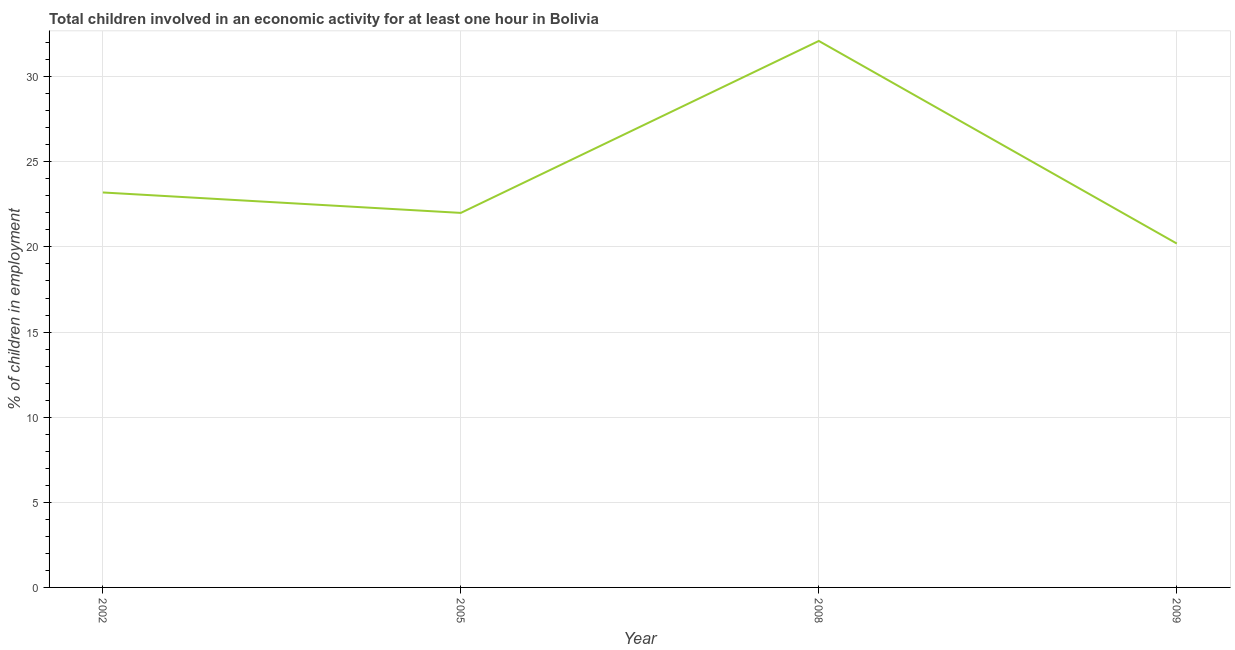What is the percentage of children in employment in 2002?
Your answer should be compact. 23.2. Across all years, what is the maximum percentage of children in employment?
Ensure brevity in your answer.  32.1. Across all years, what is the minimum percentage of children in employment?
Your answer should be very brief. 20.2. In which year was the percentage of children in employment maximum?
Provide a short and direct response. 2008. In which year was the percentage of children in employment minimum?
Make the answer very short. 2009. What is the sum of the percentage of children in employment?
Your answer should be very brief. 97.5. What is the difference between the percentage of children in employment in 2002 and 2009?
Your answer should be compact. 3. What is the average percentage of children in employment per year?
Your answer should be very brief. 24.38. What is the median percentage of children in employment?
Make the answer very short. 22.6. In how many years, is the percentage of children in employment greater than 16 %?
Offer a very short reply. 4. Do a majority of the years between 2009 and 2005 (inclusive) have percentage of children in employment greater than 8 %?
Offer a very short reply. No. What is the ratio of the percentage of children in employment in 2002 to that in 2008?
Your answer should be very brief. 0.72. Is the percentage of children in employment in 2002 less than that in 2008?
Ensure brevity in your answer.  Yes. Is the difference between the percentage of children in employment in 2002 and 2009 greater than the difference between any two years?
Your response must be concise. No. What is the difference between the highest and the second highest percentage of children in employment?
Your response must be concise. 8.9. What is the difference between the highest and the lowest percentage of children in employment?
Provide a succinct answer. 11.9. In how many years, is the percentage of children in employment greater than the average percentage of children in employment taken over all years?
Your response must be concise. 1. How many years are there in the graph?
Offer a very short reply. 4. What is the difference between two consecutive major ticks on the Y-axis?
Your response must be concise. 5. Does the graph contain any zero values?
Give a very brief answer. No. Does the graph contain grids?
Make the answer very short. Yes. What is the title of the graph?
Your response must be concise. Total children involved in an economic activity for at least one hour in Bolivia. What is the label or title of the Y-axis?
Offer a terse response. % of children in employment. What is the % of children in employment in 2002?
Provide a short and direct response. 23.2. What is the % of children in employment in 2008?
Offer a terse response. 32.1. What is the % of children in employment in 2009?
Keep it short and to the point. 20.2. What is the difference between the % of children in employment in 2002 and 2005?
Keep it short and to the point. 1.2. What is the difference between the % of children in employment in 2002 and 2008?
Offer a very short reply. -8.9. What is the difference between the % of children in employment in 2005 and 2009?
Your response must be concise. 1.8. What is the ratio of the % of children in employment in 2002 to that in 2005?
Offer a very short reply. 1.05. What is the ratio of the % of children in employment in 2002 to that in 2008?
Ensure brevity in your answer.  0.72. What is the ratio of the % of children in employment in 2002 to that in 2009?
Keep it short and to the point. 1.15. What is the ratio of the % of children in employment in 2005 to that in 2008?
Offer a very short reply. 0.69. What is the ratio of the % of children in employment in 2005 to that in 2009?
Make the answer very short. 1.09. What is the ratio of the % of children in employment in 2008 to that in 2009?
Keep it short and to the point. 1.59. 